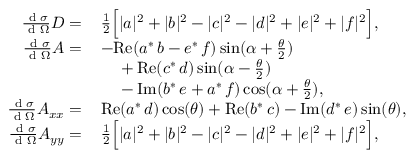Convert formula to latex. <formula><loc_0><loc_0><loc_500><loc_500>\begin{array} { r l } { \frac { d \sigma } { d \Omega } D = \, } & { \frac { 1 } { 2 } \left [ | a | ^ { 2 } + | b | ^ { 2 } - | c | ^ { 2 } - | d | ^ { 2 } + | e | ^ { 2 } + | f | ^ { 2 } \right ] , } \\ { \frac { d \sigma } { d \Omega } A = \, } & { - R e ( a ^ { * } \, b - e ^ { * } \, f ) \sin ( \alpha + \frac { \theta } { 2 } ) } \\ & { \quad \null + R e ( c ^ { * } \, d ) \sin ( \alpha - \frac { \theta } { 2 } ) } \\ & { \quad \null - I m ( b ^ { * } \, e + a ^ { * } \, f ) \cos ( \alpha + \frac { \theta } { 2 } ) , } \\ { \frac { d \sigma } { d \Omega } A _ { x x } = \, } & { R e ( a ^ { * } \, d ) \cos ( \theta ) + R e ( b ^ { * } \, c ) - I m ( d ^ { * } \, e ) \sin ( \theta ) , } \\ { \frac { d \sigma } { d \Omega } A _ { y y } = \, } & { \frac { 1 } { 2 } \left [ | a | ^ { 2 } + | b | ^ { 2 } - | c | ^ { 2 } - | d | ^ { 2 } + | e | ^ { 2 } + | f | ^ { 2 } \right ] , } \end{array}</formula> 